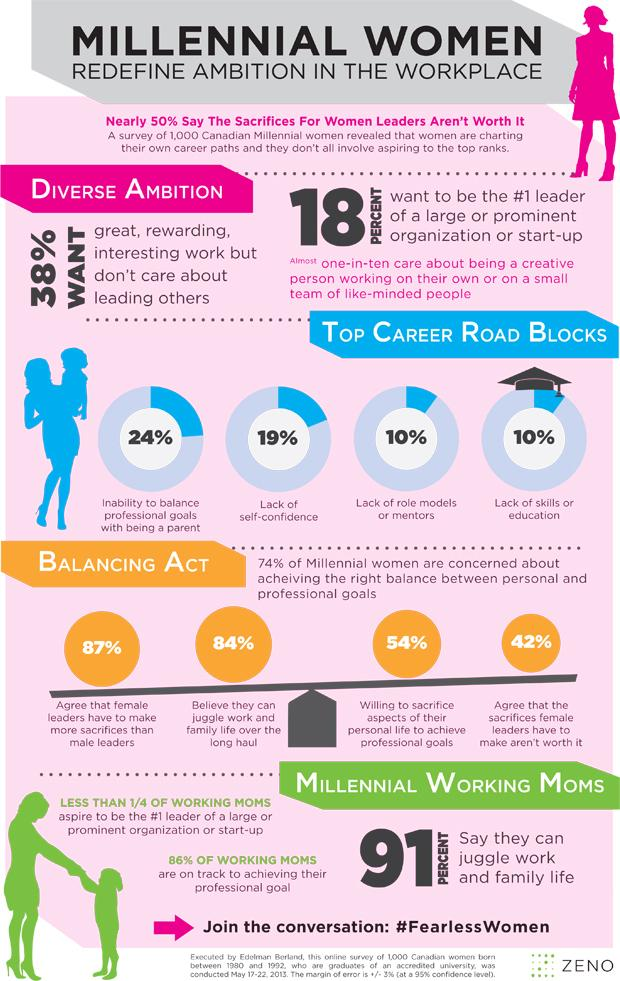Specify some key components in this picture. According to a recent survey, 90% of career roadblocks for women are not due to a lack of role models or mentors. According to recent studies, the overwhelming majority of career roadblocks faced by women are not due to a lack of skills or education, but rather systemic biases and discrimination. Specifically, 90% of career roadblocks for women are attributed to factors such as gender stereotypes, limited access to leadership roles, and unequal pay. These findings highlight the urgent need for organizations and individuals to take proactive steps to address and overcome these barriers in order to promote gender equality in the workplace. According to a recent survey, 82% of women do not aspire to be the #1 leader of a large or prominent organization or start-up. According to a survey, only 19% of career roadblocks for women are due to a lack of confidence. According to the survey, only 76% of the career roadblocks faced by women are not due to their inability to balance professional goals with being a parent. 